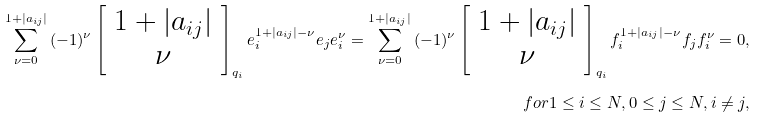<formula> <loc_0><loc_0><loc_500><loc_500>\sum _ { \nu = 0 } ^ { 1 + | a _ { i j } | } { ( - 1 ) ^ { \nu } } \left [ \begin{array} { c } 1 + | a _ { i j } | \\ \nu \end{array} \right ] _ { q _ { i } } e _ { i } ^ { 1 + | a _ { i j } | - { \nu } } e _ { j } e _ { i } ^ { \nu } = \sum _ { \nu = 0 } ^ { 1 + | a _ { i j } | } { ( - 1 ) ^ { \nu } } \left [ \begin{array} { c } 1 + | a _ { i j } | \\ \nu \end{array} \right ] _ { q _ { i } } f _ { i } ^ { 1 + | a _ { i j } | - { \nu } } f _ { j } f _ { i } ^ { \nu } = 0 , \\ f o r 1 \leq i \leq N , 0 \leq j \leq N , i \neq j ,</formula> 